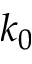<formula> <loc_0><loc_0><loc_500><loc_500>k _ { 0 }</formula> 